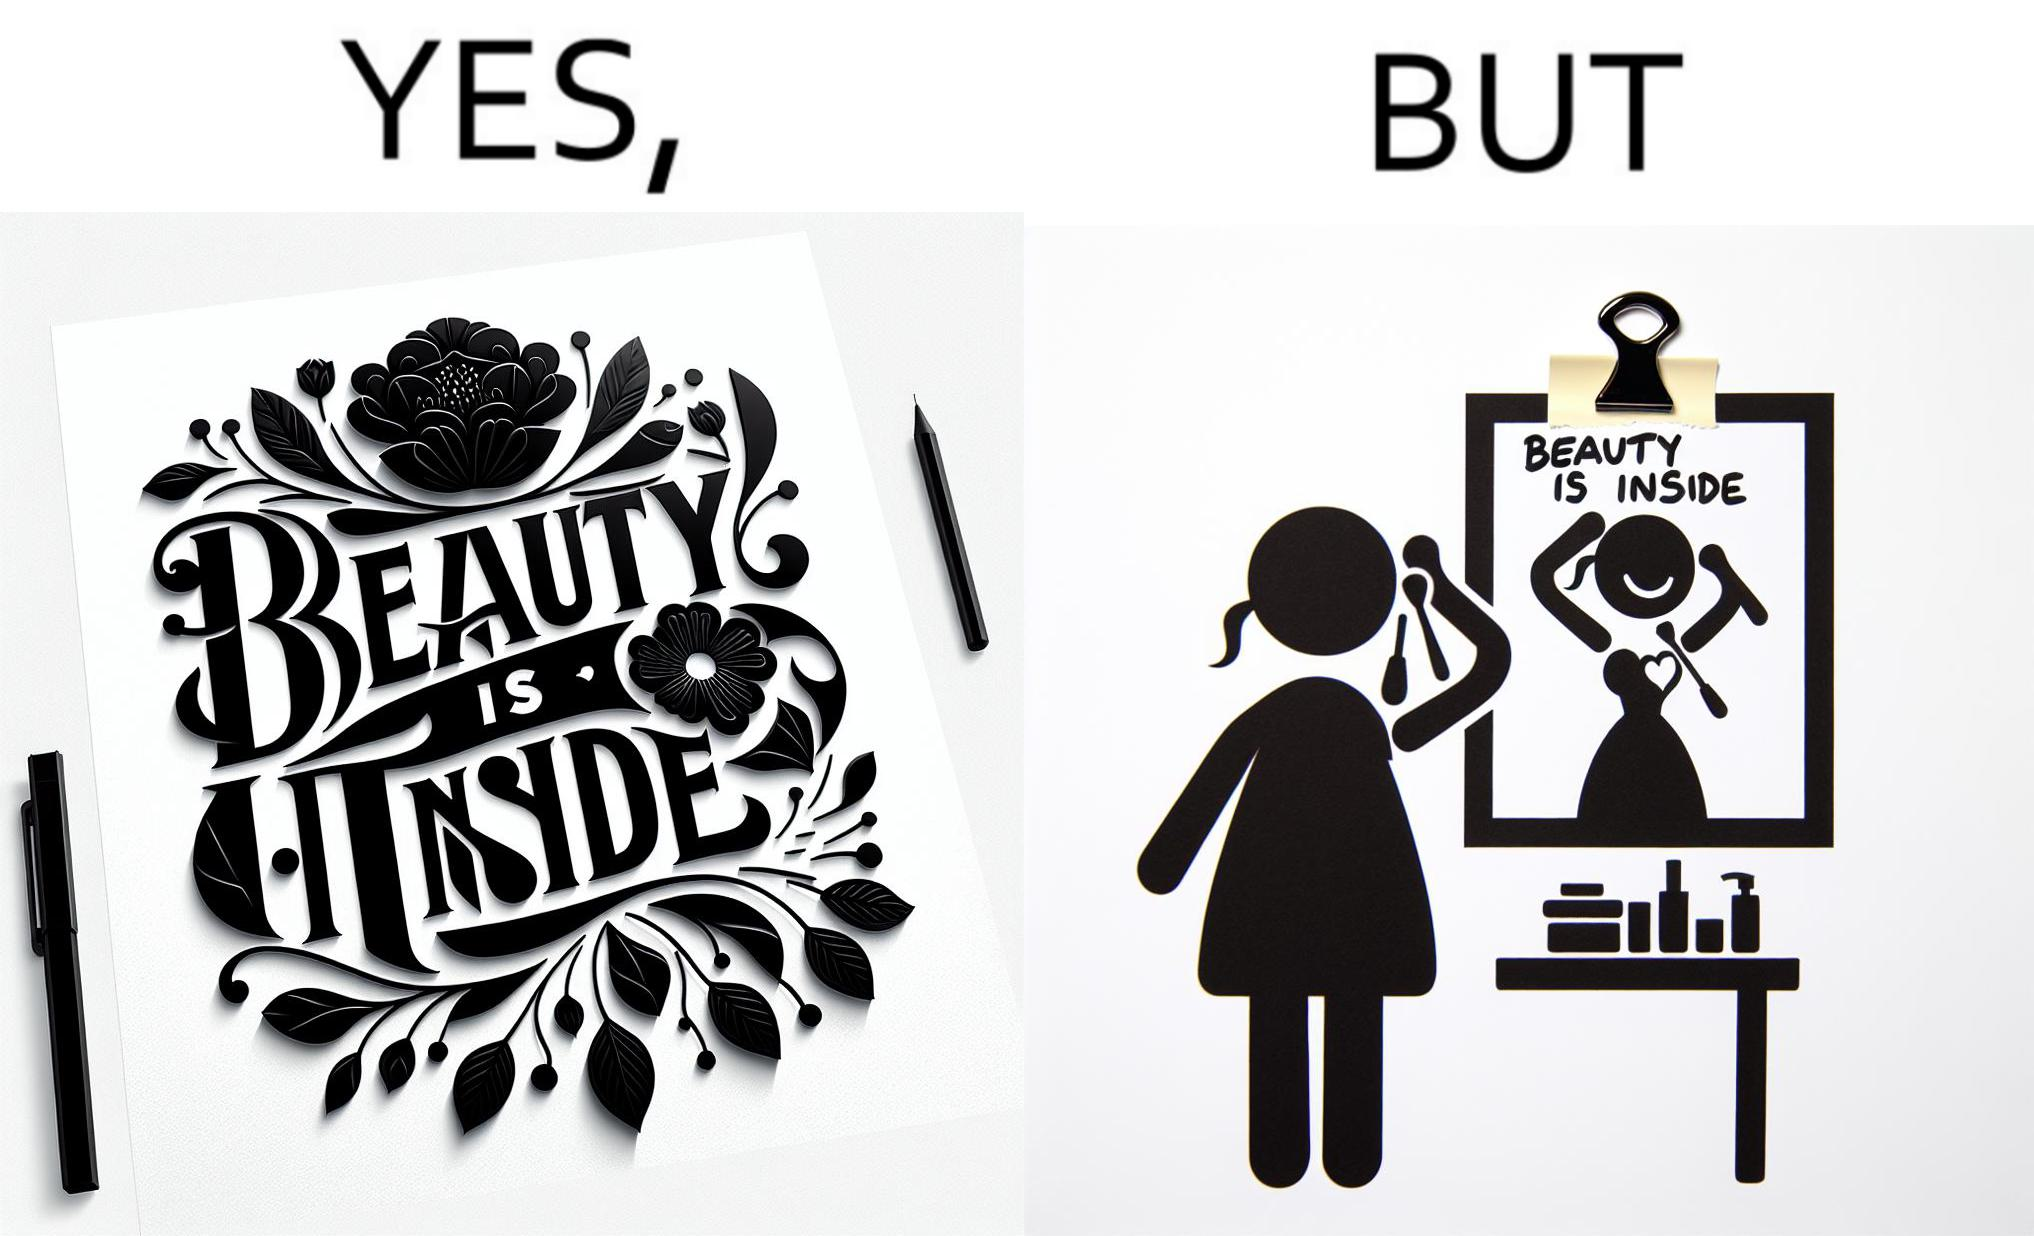Does this image contain satire or humor? Yes, this image is satirical. 